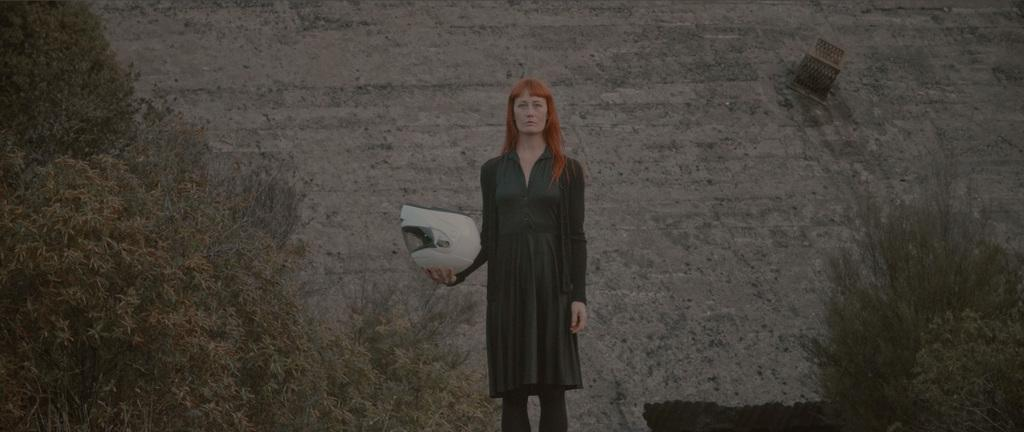Who is the main subject in the image? There is a lady in the image. Where is the lady positioned in the image? The lady is standing in the center of the image. What is the lady holding in her hand? The lady is holding a helmet in her hand. What can be seen on both sides of the image? There are trees on the right side and the left side of the image. What type of quill is the lady using to write a note during the meeting in the image? There is no quill or meeting present in the image. The lady is holding a helmet, not a quill. 